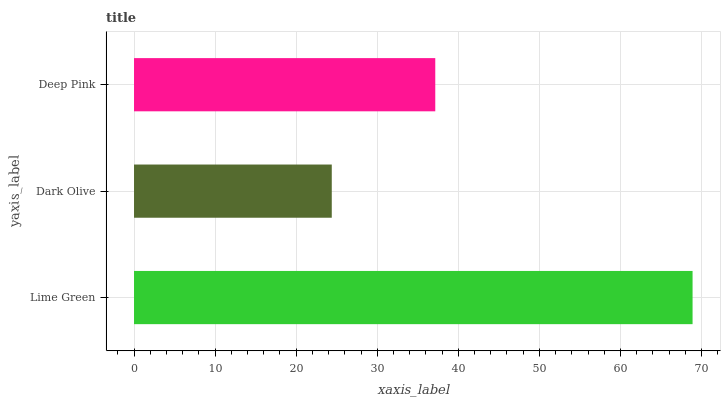Is Dark Olive the minimum?
Answer yes or no. Yes. Is Lime Green the maximum?
Answer yes or no. Yes. Is Deep Pink the minimum?
Answer yes or no. No. Is Deep Pink the maximum?
Answer yes or no. No. Is Deep Pink greater than Dark Olive?
Answer yes or no. Yes. Is Dark Olive less than Deep Pink?
Answer yes or no. Yes. Is Dark Olive greater than Deep Pink?
Answer yes or no. No. Is Deep Pink less than Dark Olive?
Answer yes or no. No. Is Deep Pink the high median?
Answer yes or no. Yes. Is Deep Pink the low median?
Answer yes or no. Yes. Is Lime Green the high median?
Answer yes or no. No. Is Lime Green the low median?
Answer yes or no. No. 